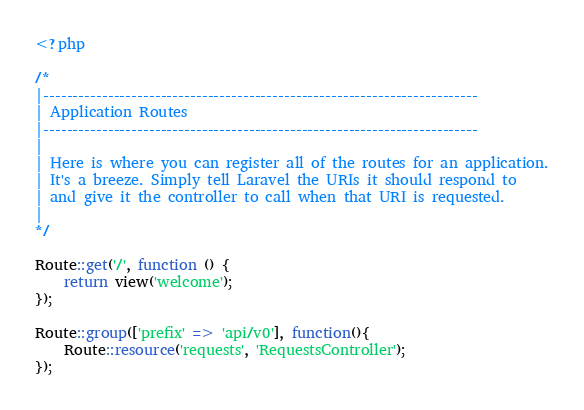Convert code to text. <code><loc_0><loc_0><loc_500><loc_500><_PHP_><?php

/*
|--------------------------------------------------------------------------
| Application Routes
|--------------------------------------------------------------------------
|
| Here is where you can register all of the routes for an application.
| It's a breeze. Simply tell Laravel the URIs it should respond to
| and give it the controller to call when that URI is requested.
|
*/

Route::get('/', function () {
    return view('welcome');
});

Route::group(['prefix' => 'api/v0'], function(){
	Route::resource('requests', 'RequestsController');
});
</code> 